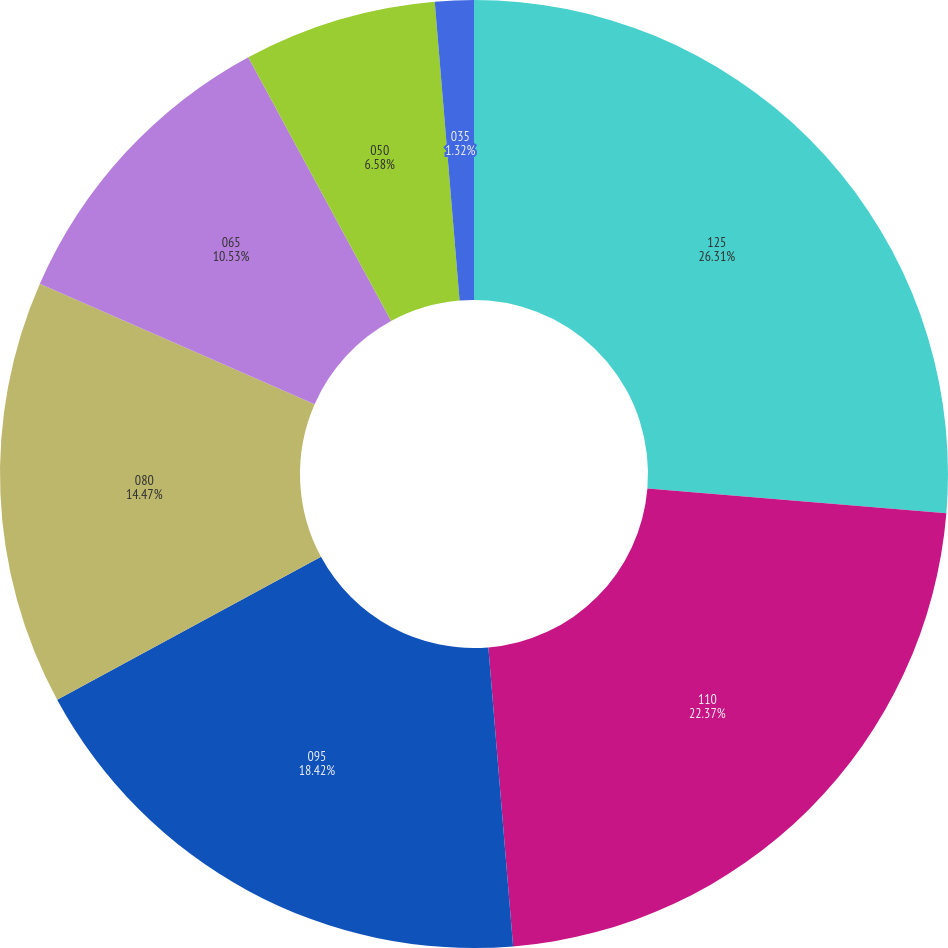Convert chart. <chart><loc_0><loc_0><loc_500><loc_500><pie_chart><fcel>125<fcel>110<fcel>095<fcel>080<fcel>065<fcel>050<fcel>035<nl><fcel>26.32%<fcel>22.37%<fcel>18.42%<fcel>14.47%<fcel>10.53%<fcel>6.58%<fcel>1.32%<nl></chart> 